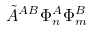<formula> <loc_0><loc_0><loc_500><loc_500>\tilde { A } ^ { A B } \Phi _ { n } ^ { A } \Phi _ { m } ^ { B }</formula> 